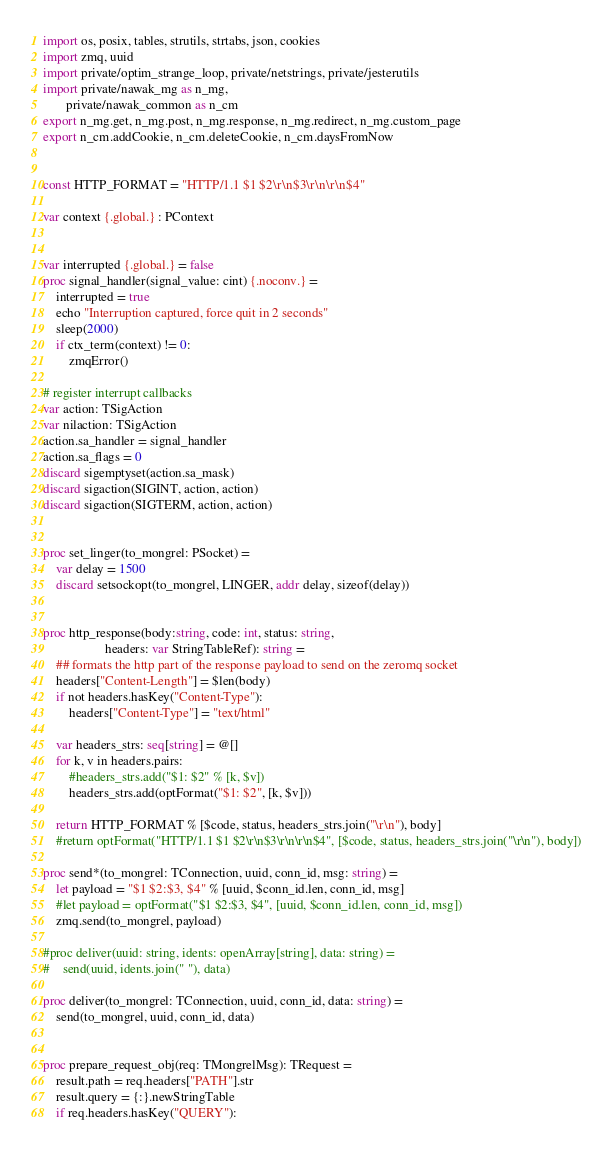Convert code to text. <code><loc_0><loc_0><loc_500><loc_500><_Nim_>import os, posix, tables, strutils, strtabs, json, cookies
import zmq, uuid
import private/optim_strange_loop, private/netstrings, private/jesterutils
import private/nawak_mg as n_mg,
       private/nawak_common as n_cm
export n_mg.get, n_mg.post, n_mg.response, n_mg.redirect, n_mg.custom_page
export n_cm.addCookie, n_cm.deleteCookie, n_cm.daysFromNow


const HTTP_FORMAT = "HTTP/1.1 $1 $2\r\n$3\r\n\r\n$4"

var context {.global.} : PContext


var interrupted {.global.} = false
proc signal_handler(signal_value: cint) {.noconv.} =
    interrupted = true
    echo "Interruption captured, force quit in 2 seconds"
    sleep(2000)
    if ctx_term(context) != 0:
        zmqError()

# register interrupt callbacks
var action: TSigAction
var nilaction: TSigAction
action.sa_handler = signal_handler
action.sa_flags = 0
discard sigemptyset(action.sa_mask)
discard sigaction(SIGINT, action, action)
discard sigaction(SIGTERM, action, action)


proc set_linger(to_mongrel: PSocket) =
    var delay = 1500
    discard setsockopt(to_mongrel, LINGER, addr delay, sizeof(delay))


proc http_response(body:string, code: int, status: string,
                   headers: var StringTableRef): string =
    ## formats the http part of the response payload to send on the zeromq socket
    headers["Content-Length"] = $len(body)
    if not headers.hasKey("Content-Type"):
        headers["Content-Type"] = "text/html"

    var headers_strs: seq[string] = @[]
    for k, v in headers.pairs:
        #headers_strs.add("$1: $2" % [k, $v])
        headers_strs.add(optFormat("$1: $2", [k, $v]))

    return HTTP_FORMAT % [$code, status, headers_strs.join("\r\n"), body]
    #return optFormat("HTTP/1.1 $1 $2\r\n$3\r\n\r\n$4", [$code, status, headers_strs.join("\r\n"), body])

proc send*(to_mongrel: TConnection, uuid, conn_id, msg: string) =
    let payload = "$1 $2:$3, $4" % [uuid, $conn_id.len, conn_id, msg]
    #let payload = optFormat("$1 $2:$3, $4", [uuid, $conn_id.len, conn_id, msg])
    zmq.send(to_mongrel, payload)

#proc deliver(uuid: string, idents: openArray[string], data: string) =
#    send(uuid, idents.join(" "), data)

proc deliver(to_mongrel: TConnection, uuid, conn_id, data: string) =
    send(to_mongrel, uuid, conn_id, data)


proc prepare_request_obj(req: TMongrelMsg): TRequest =
    result.path = req.headers["PATH"].str
    result.query = {:}.newStringTable
    if req.headers.hasKey("QUERY"):</code> 